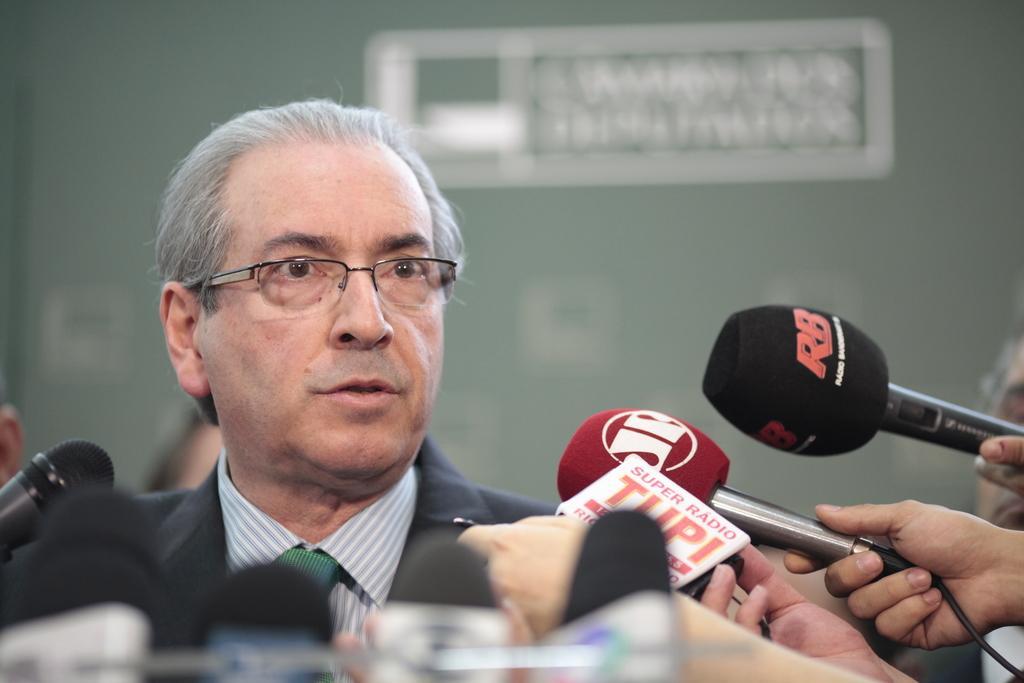Describe this image in one or two sentences. In this picture there is a old man wearing black color coat with specs standing to talk with media. In the front there are many microphones. Behind there is a grey color wall. 